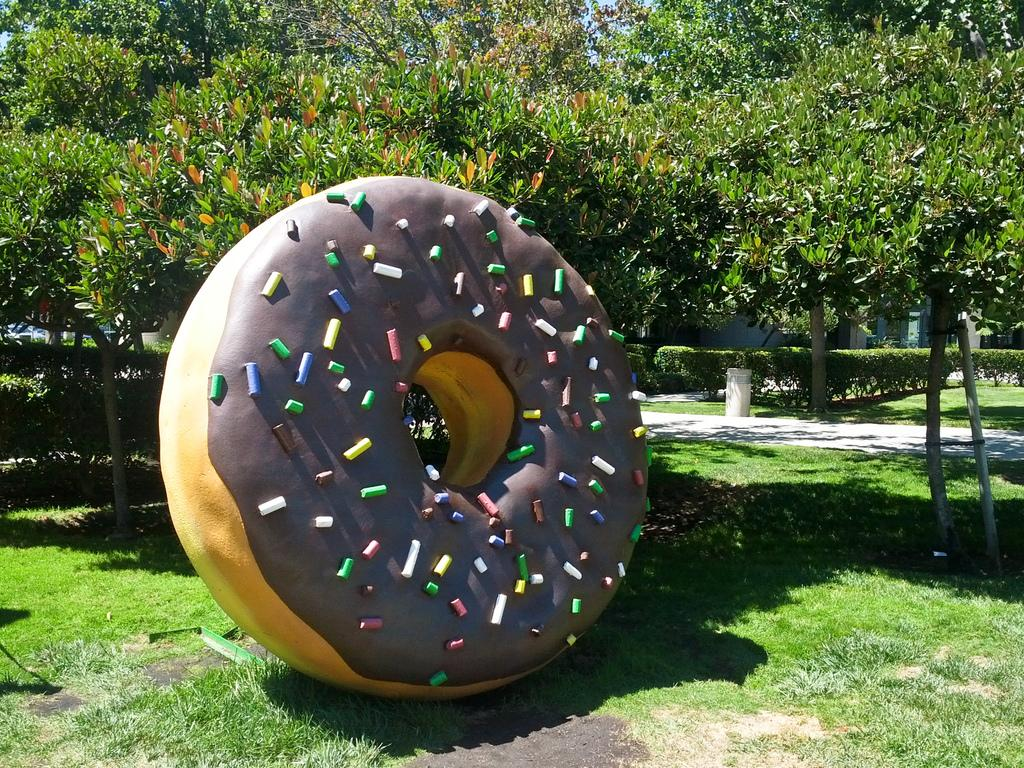What is the main subject in the foreground of the picture? There is a structure of doughnut in the foreground of the picture. Where is the structure of doughnut located? The structure of doughnut is on the grass. What can be seen in the background of the image? There are trees, grass, a bollard, plants, and the sky visible in the background of the image. What type of toys are scattered around the doughnut structure in the image? There are no toys present in the image; it features a structure of doughnut on the grass with a background of trees, grass, a bollard, plants, and the sky. 